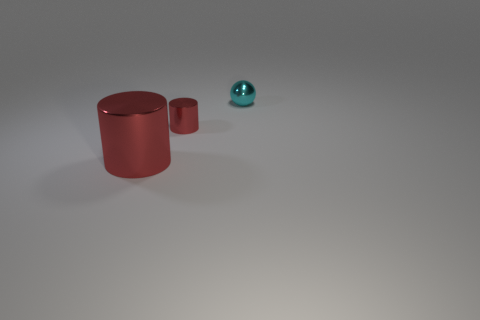What number of tiny objects are either red shiny things or brown shiny cylinders?
Offer a very short reply. 1. There is a small shiny object that is in front of the sphere; does it have the same color as the cylinder on the left side of the small cylinder?
Offer a terse response. Yes. What number of other objects are there of the same color as the big object?
Ensure brevity in your answer.  1. There is a tiny object to the left of the small cyan sphere; what shape is it?
Keep it short and to the point. Cylinder. Is the number of large cylinders less than the number of red cylinders?
Keep it short and to the point. Yes. Is the tiny thing that is to the left of the cyan object made of the same material as the big cylinder?
Make the answer very short. Yes. There is a large shiny object; are there any red metal cylinders on the right side of it?
Keep it short and to the point. Yes. What color is the tiny object that is in front of the metallic thing to the right of the tiny metal object in front of the cyan object?
Offer a very short reply. Red. What shape is the red thing that is the same size as the cyan sphere?
Ensure brevity in your answer.  Cylinder. Is the number of green rubber blocks greater than the number of big red metallic cylinders?
Provide a short and direct response. No. 